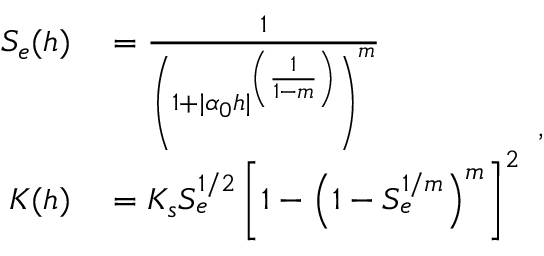Convert formula to latex. <formula><loc_0><loc_0><loc_500><loc_500>\begin{array} { r l } { S _ { e } ( h ) } & = \frac { 1 } { \left ( 1 + | \alpha _ { 0 } h | ^ { \left ( \frac { 1 } { 1 - m } \right ) } \right ) ^ { m } } } \\ { K ( h ) } & = K _ { s } S _ { e } ^ { 1 / 2 } \left [ 1 - \left ( 1 - S _ { e } ^ { 1 / m } \right ) ^ { m } \right ] ^ { 2 } } \end{array} ,</formula> 